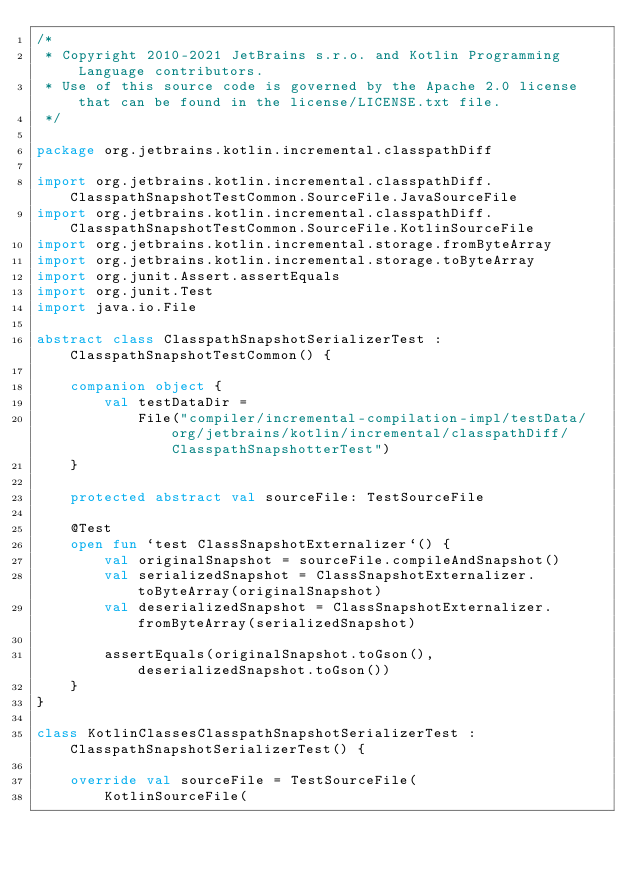<code> <loc_0><loc_0><loc_500><loc_500><_Kotlin_>/*
 * Copyright 2010-2021 JetBrains s.r.o. and Kotlin Programming Language contributors.
 * Use of this source code is governed by the Apache 2.0 license that can be found in the license/LICENSE.txt file.
 */

package org.jetbrains.kotlin.incremental.classpathDiff

import org.jetbrains.kotlin.incremental.classpathDiff.ClasspathSnapshotTestCommon.SourceFile.JavaSourceFile
import org.jetbrains.kotlin.incremental.classpathDiff.ClasspathSnapshotTestCommon.SourceFile.KotlinSourceFile
import org.jetbrains.kotlin.incremental.storage.fromByteArray
import org.jetbrains.kotlin.incremental.storage.toByteArray
import org.junit.Assert.assertEquals
import org.junit.Test
import java.io.File

abstract class ClasspathSnapshotSerializerTest : ClasspathSnapshotTestCommon() {

    companion object {
        val testDataDir =
            File("compiler/incremental-compilation-impl/testData/org/jetbrains/kotlin/incremental/classpathDiff/ClasspathSnapshotterTest")
    }

    protected abstract val sourceFile: TestSourceFile

    @Test
    open fun `test ClassSnapshotExternalizer`() {
        val originalSnapshot = sourceFile.compileAndSnapshot()
        val serializedSnapshot = ClassSnapshotExternalizer.toByteArray(originalSnapshot)
        val deserializedSnapshot = ClassSnapshotExternalizer.fromByteArray(serializedSnapshot)

        assertEquals(originalSnapshot.toGson(), deserializedSnapshot.toGson())
    }
}

class KotlinClassesClasspathSnapshotSerializerTest : ClasspathSnapshotSerializerTest() {

    override val sourceFile = TestSourceFile(
        KotlinSourceFile(</code> 